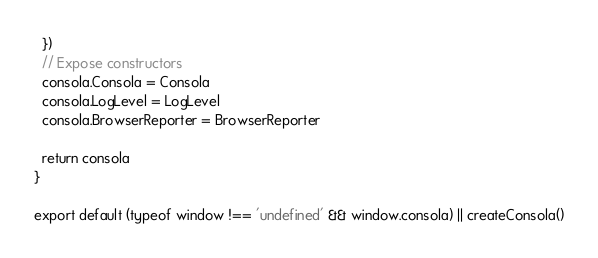Convert code to text. <code><loc_0><loc_0><loc_500><loc_500><_JavaScript_>  })
  // Expose constructors
  consola.Consola = Consola
  consola.LogLevel = LogLevel
  consola.BrowserReporter = BrowserReporter

  return consola
}

export default (typeof window !== 'undefined' && window.consola) || createConsola()
</code> 